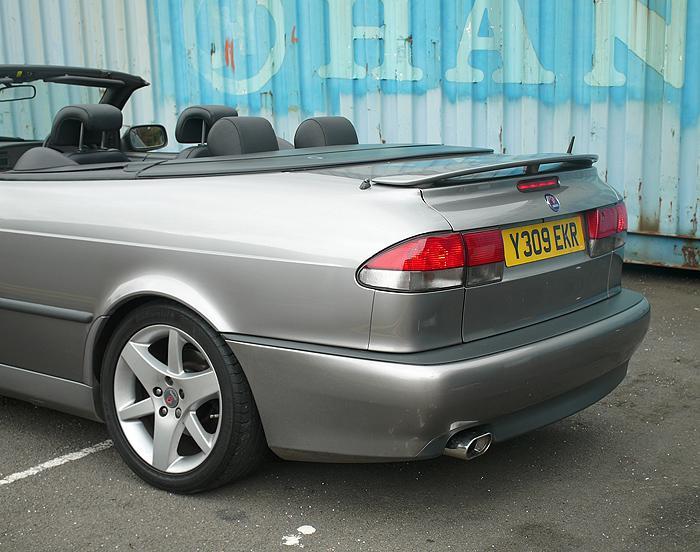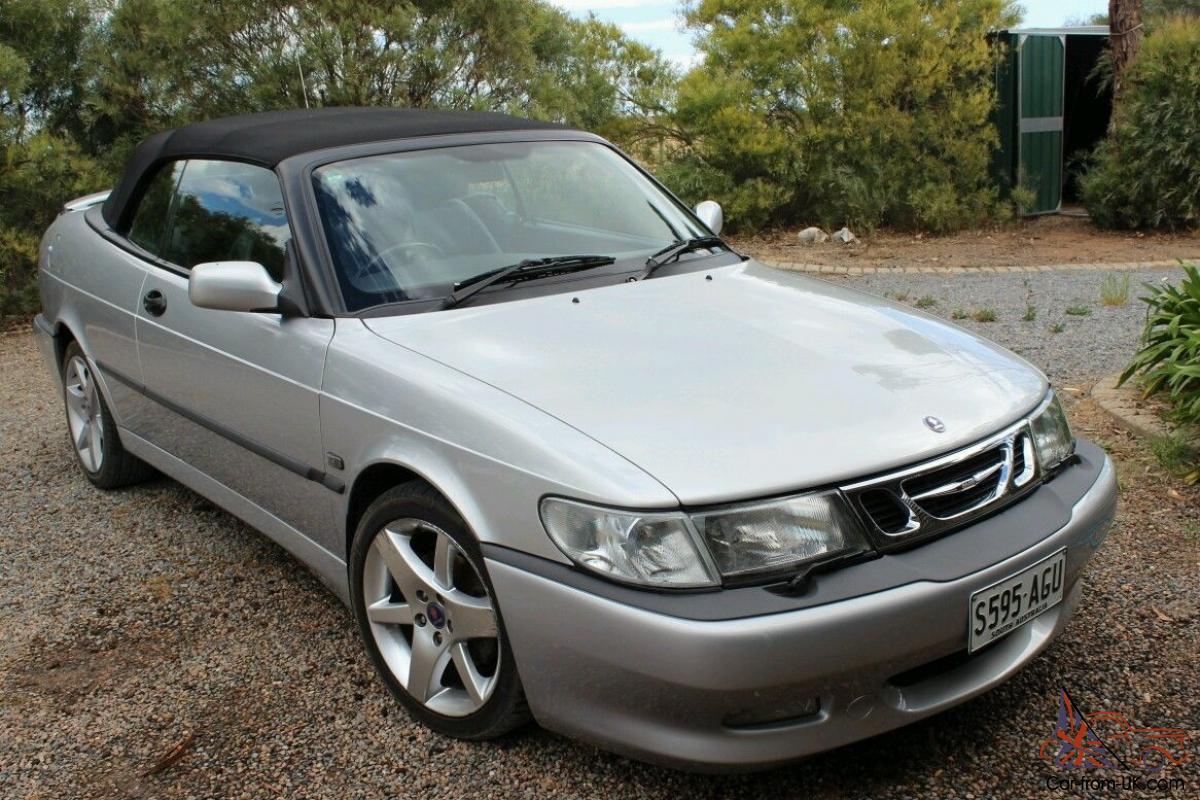The first image is the image on the left, the second image is the image on the right. Evaluate the accuracy of this statement regarding the images: "Each image shows a grey convertible.". Is it true? Answer yes or no. Yes. The first image is the image on the left, the second image is the image on the right. For the images displayed, is the sentence "The convertible in the right image has its top off." factually correct? Answer yes or no. No. 